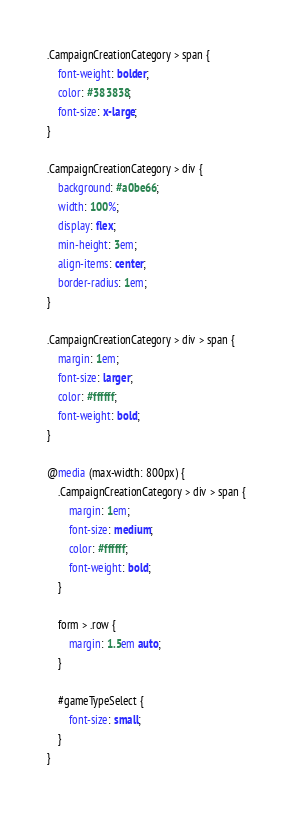Convert code to text. <code><loc_0><loc_0><loc_500><loc_500><_CSS_>.CampaignCreationCategory > span {
    font-weight: bolder;
    color: #383838;
    font-size: x-large;
}

.CampaignCreationCategory > div {
    background: #a0be66;
    width: 100%;
    display: flex;
    min-height: 3em;
    align-items: center;
    border-radius: 1em;
}

.CampaignCreationCategory > div > span {
    margin: 1em;
    font-size: larger;
    color: #ffffff;
    font-weight: bold;
}

@media (max-width: 800px) {
    .CampaignCreationCategory > div > span {
        margin: 1em;
        font-size: medium;
        color: #ffffff;
        font-weight: bold;
    }

    form > .row {
        margin: 1.5em auto;
    }

    #gameTypeSelect {
        font-size: small;
    }
}</code> 